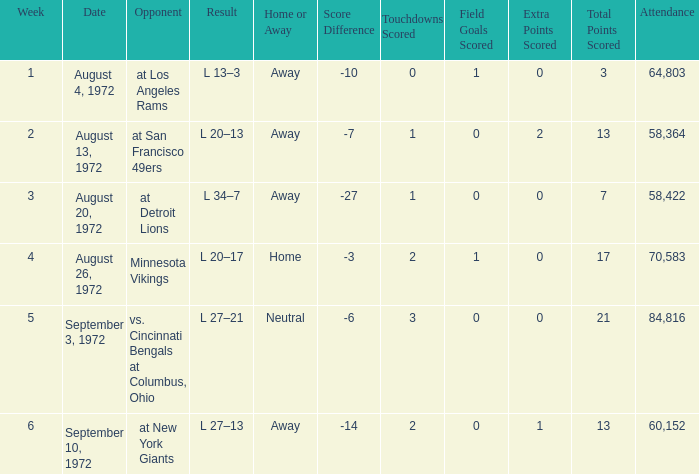What is the lowest attendance on September 3, 1972? 84816.0. 